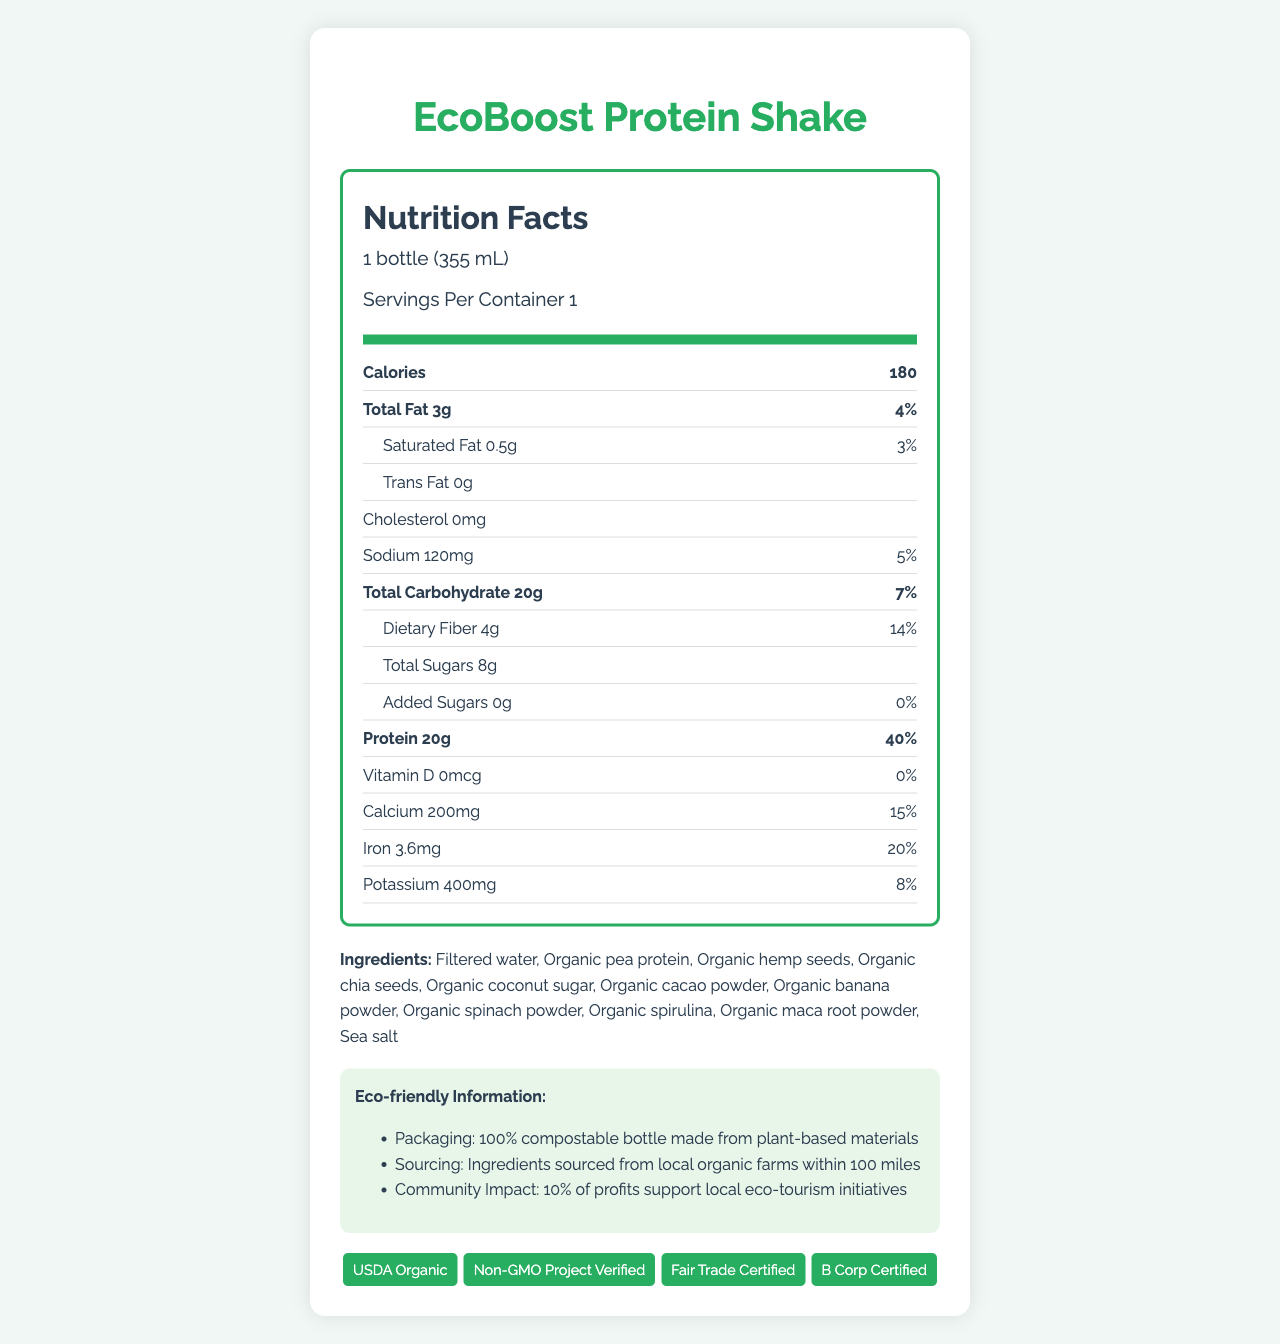what is the serving size of EcoBoost Protein Shake? The serving size is listed at the top of the nutrition label as "1 bottle (355 mL)".
Answer: 1 bottle (355 mL) how many calories does one serving of EcoBoost Protein Shake contain? The calories per serving are clearly stated on the label as 180.
Answer: 180 what is the amount of protein per serving? The protein amount is listed in the nutrition facts as 20g per serving.
Answer: 20g does the protein shake contain any cholesterol? The label indicates 0mg of cholesterol.
Answer: No how much dietary fiber is in one serving? The dietary fiber amount is noted as 4g per serving.
Answer: 4g what percentage of daily value does the total fat contribute? A. 4% B. 5% C. 7% D. 10% The nutrition label states that the total fat contributes 4% to the daily value.
Answer: A what is the community impact of this product? A. 5% of profits support local eco-tourism B. 10% of profits support local eco-tourism C. 15% of profits support local eco-tourism D. 20% of profits support local eco-tourism The eco-friendly information section mentions that 10% of profits support local eco-tourism initiatives.
Answer: B is the bottle of EcoBoost Protein Shake compostable? The eco-friendly information section specifies that the bottle is 100% compostable.
Answer: Yes what certifications does the EcoBoost Protein Shake have? The certifications are listed at the bottom of the document under the certifications section.
Answer: USDA Organic, Non-GMO Project Verified, Fair Trade Certified, B Corp Certified is there any added sugar in the shake? The nutrition label clearly states that the amount of added sugars is 0g, which means there is no added sugar in the shake.
Answer: No describe the main idea of the document. The document provides comprehensive information on the nutritional content, eco-friendly aspects, and certifications of the EcoBoost Protein Shake, ensuring both health-conscious and environmentally-conscious consumers understand its benefits and contributions.
Answer: The document is a detailed Nutrition Facts Label for EcoBoost Protein Shake, highlighting its nutritional values, ingredients, eco-friendly packaging, and sourcing information. It also mentions the product's certifications and community impact. what is the exact amount of vitamin D in the shake? The exact amount of vitamin D is listed as 0mcg in the nutrition facts.
Answer: 0mcg where are the ingredients sourced from? The eco-friendly information section mentions that ingredients are sourced from local organic farms within 100 miles, but it doesn't specify exact locations.
Answer: Not enough information what is the total grams of sugar in one serving? The total sugars in one serving are listed as 8g.
Answer: 8g which of the following ingredients is not in the shake? A. Organic chia seeds B. Organic molasses C. Organic spirulina D. Sea salt Organic molasses is not listed among the ingredients, while the other options are.
Answer: B 